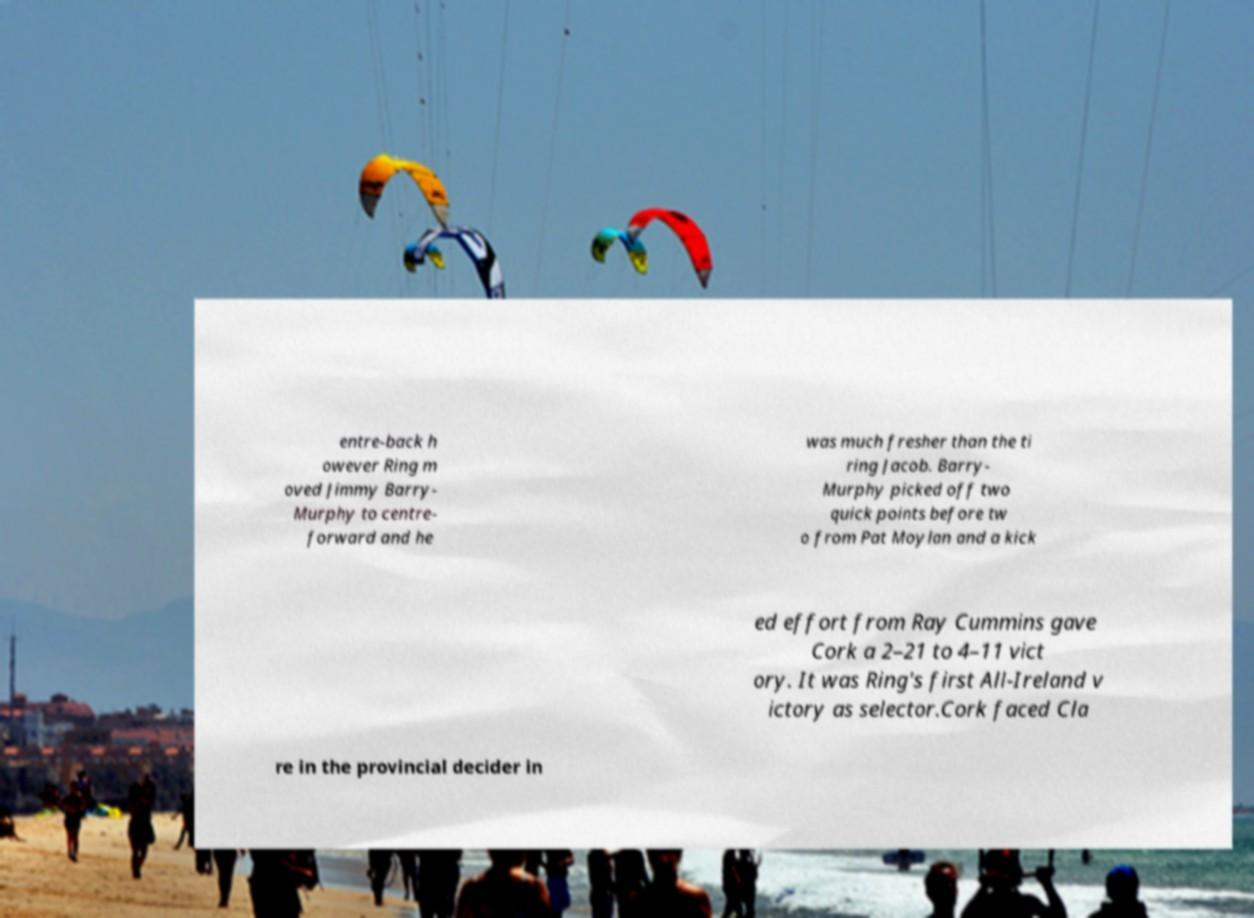Can you accurately transcribe the text from the provided image for me? entre-back h owever Ring m oved Jimmy Barry- Murphy to centre- forward and he was much fresher than the ti ring Jacob. Barry- Murphy picked off two quick points before tw o from Pat Moylan and a kick ed effort from Ray Cummins gave Cork a 2–21 to 4–11 vict ory. It was Ring's first All-Ireland v ictory as selector.Cork faced Cla re in the provincial decider in 